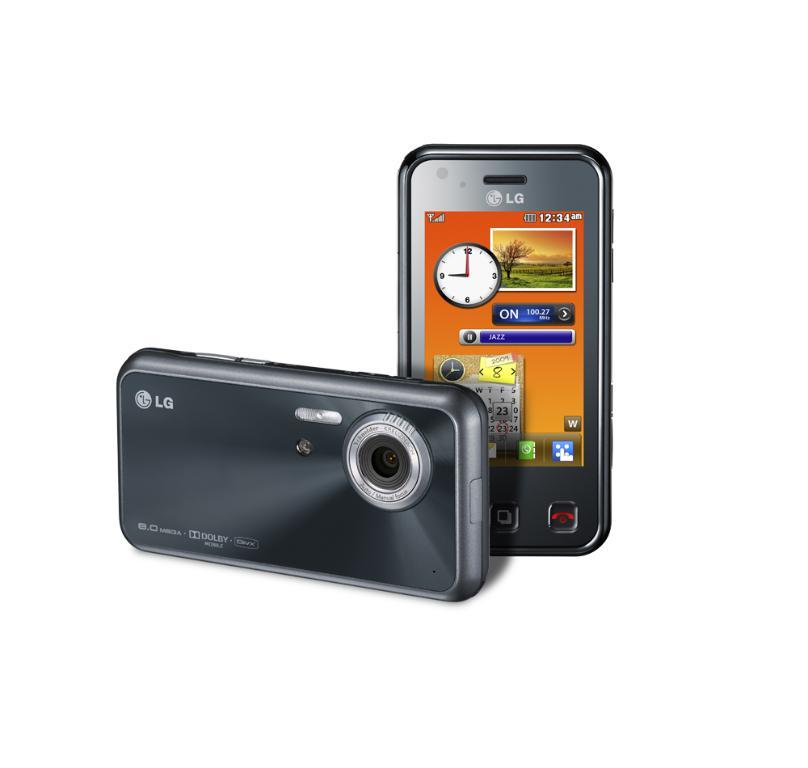<image>
Write a terse but informative summary of the picture. An LG, touch screen phone is displayed behind the same phone, turned around and laid horizontal, so that the back of the phone appears as a camera. 